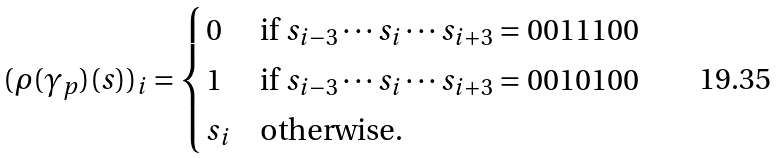<formula> <loc_0><loc_0><loc_500><loc_500>( \rho ( \gamma _ { p } ) ( s ) ) _ { i } = \begin{cases} 0 & \text {if } s _ { i - 3 } \cdots s _ { i } \cdots s _ { i + 3 } = 0 0 1 1 1 0 0 \\ 1 & \text {if } s _ { i - 3 } \cdots s _ { i } \cdots s _ { i + 3 } = 0 0 1 0 1 0 0 \\ s _ { i } & \text {otherwise.} \end{cases}</formula> 